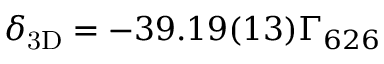<formula> <loc_0><loc_0><loc_500><loc_500>{ \delta _ { 3 D } } = - 3 9 . 1 9 ( 1 3 ) { \Gamma _ { 6 2 6 } }</formula> 